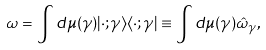<formula> <loc_0><loc_0><loc_500><loc_500>\omega = \int d \mu ( \gamma ) | \cdot ; \gamma \rangle \langle \cdot ; \gamma | \equiv \int d \mu ( \gamma ) \hat { \omega } _ { \gamma } ,</formula> 